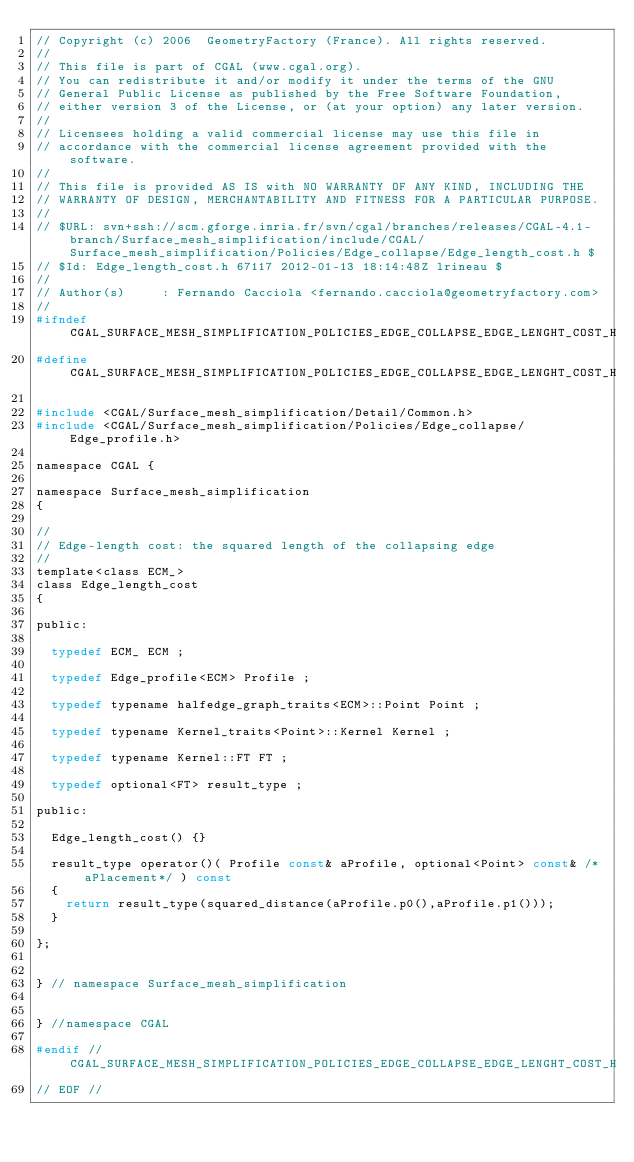<code> <loc_0><loc_0><loc_500><loc_500><_C_>// Copyright (c) 2006  GeometryFactory (France). All rights reserved.
//
// This file is part of CGAL (www.cgal.org).
// You can redistribute it and/or modify it under the terms of the GNU
// General Public License as published by the Free Software Foundation,
// either version 3 of the License, or (at your option) any later version.
//
// Licensees holding a valid commercial license may use this file in
// accordance with the commercial license agreement provided with the software.
//
// This file is provided AS IS with NO WARRANTY OF ANY KIND, INCLUDING THE
// WARRANTY OF DESIGN, MERCHANTABILITY AND FITNESS FOR A PARTICULAR PURPOSE.
//
// $URL: svn+ssh://scm.gforge.inria.fr/svn/cgal/branches/releases/CGAL-4.1-branch/Surface_mesh_simplification/include/CGAL/Surface_mesh_simplification/Policies/Edge_collapse/Edge_length_cost.h $
// $Id: Edge_length_cost.h 67117 2012-01-13 18:14:48Z lrineau $
//
// Author(s)     : Fernando Cacciola <fernando.cacciola@geometryfactory.com>
//
#ifndef CGAL_SURFACE_MESH_SIMPLIFICATION_POLICIES_EDGE_COLLAPSE_EDGE_LENGHT_COST_H
#define CGAL_SURFACE_MESH_SIMPLIFICATION_POLICIES_EDGE_COLLAPSE_EDGE_LENGHT_COST_H

#include <CGAL/Surface_mesh_simplification/Detail/Common.h>
#include <CGAL/Surface_mesh_simplification/Policies/Edge_collapse/Edge_profile.h>

namespace CGAL {

namespace Surface_mesh_simplification
{

//
// Edge-length cost: the squared length of the collapsing edge
//
template<class ECM_>
class Edge_length_cost
{
  
public:
    
  typedef ECM_ ECM ;
  
  typedef Edge_profile<ECM> Profile ;
  
  typedef typename halfedge_graph_traits<ECM>::Point Point ;
  
  typedef typename Kernel_traits<Point>::Kernel Kernel ;

  typedef typename Kernel::FT FT ;
  
  typedef optional<FT> result_type ;
  
public:

  Edge_length_cost() {}
  
  result_type operator()( Profile const& aProfile, optional<Point> const& /*aPlacement*/ ) const
  {
    return result_type(squared_distance(aProfile.p0(),aProfile.p1()));
  }
  
};


} // namespace Surface_mesh_simplification


} //namespace CGAL

#endif // CGAL_SURFACE_MESH_SIMPLIFICATION_POLICIES_EDGE_COLLAPSE_EDGE_LENGHT_COST_H
// EOF //
 
</code> 